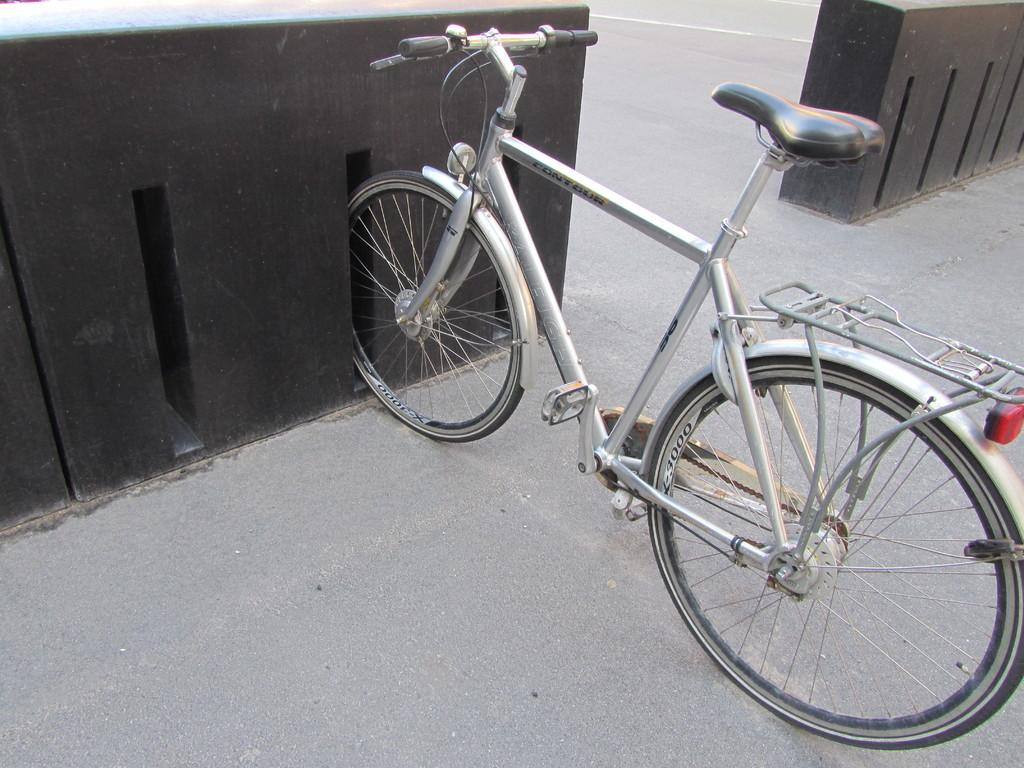What is the main object in the image? There is a bicycle in the image. What can be seen in the background of the image? There are parking slots in the image. Where is the ocean visible in the image? There is no ocean present in the image; it only features a bicycle and parking slots. 